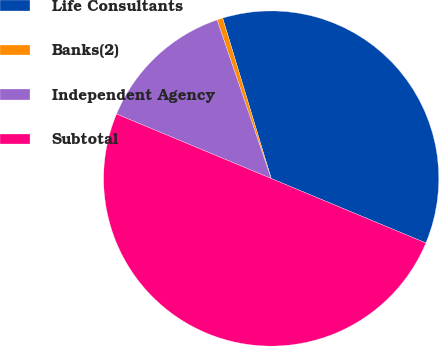<chart> <loc_0><loc_0><loc_500><loc_500><pie_chart><fcel>Life Consultants<fcel>Banks(2)<fcel>Independent Agency<fcel>Subtotal<nl><fcel>35.96%<fcel>0.56%<fcel>13.48%<fcel>50.0%<nl></chart> 